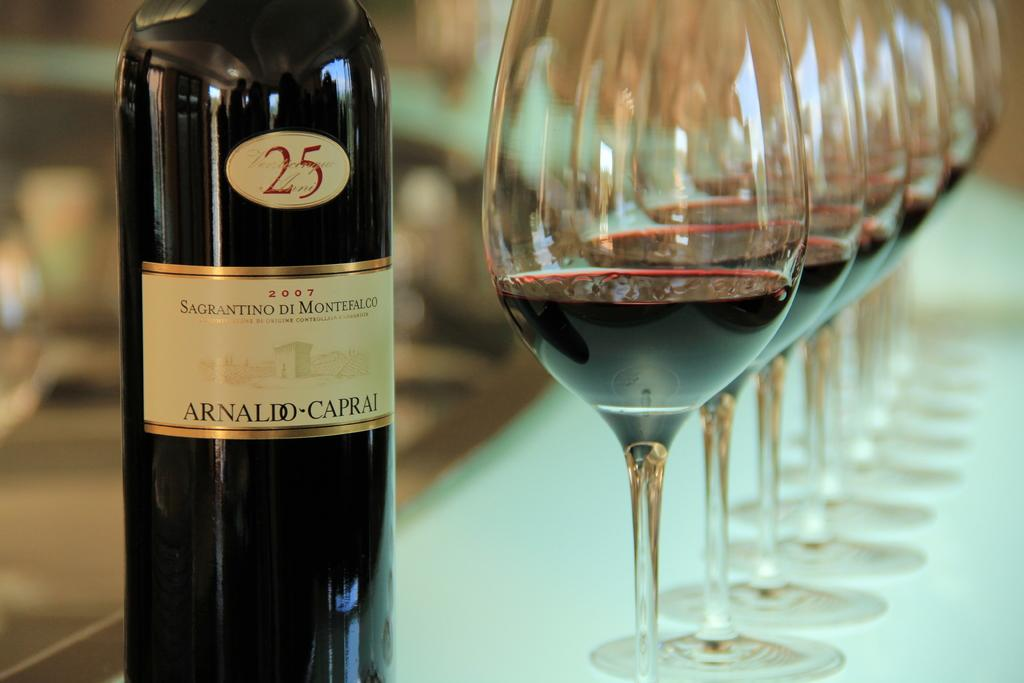<image>
Render a clear and concise summary of the photo. A bottle of Arnaldo Caprai wine is next to several glasses of wine. 